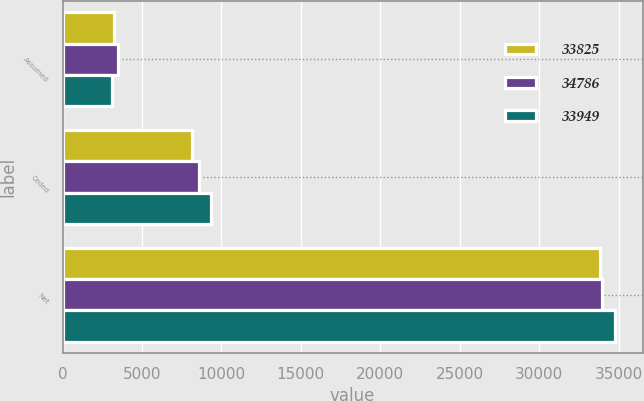Convert chart. <chart><loc_0><loc_0><loc_500><loc_500><stacked_bar_chart><ecel><fcel>Assumed<fcel>Ceded<fcel>Net<nl><fcel>33825<fcel>3258<fcel>8140<fcel>33825<nl><fcel>34786<fcel>3516<fcel>8585<fcel>33949<nl><fcel>33949<fcel>3133<fcel>9375<fcel>34786<nl></chart> 